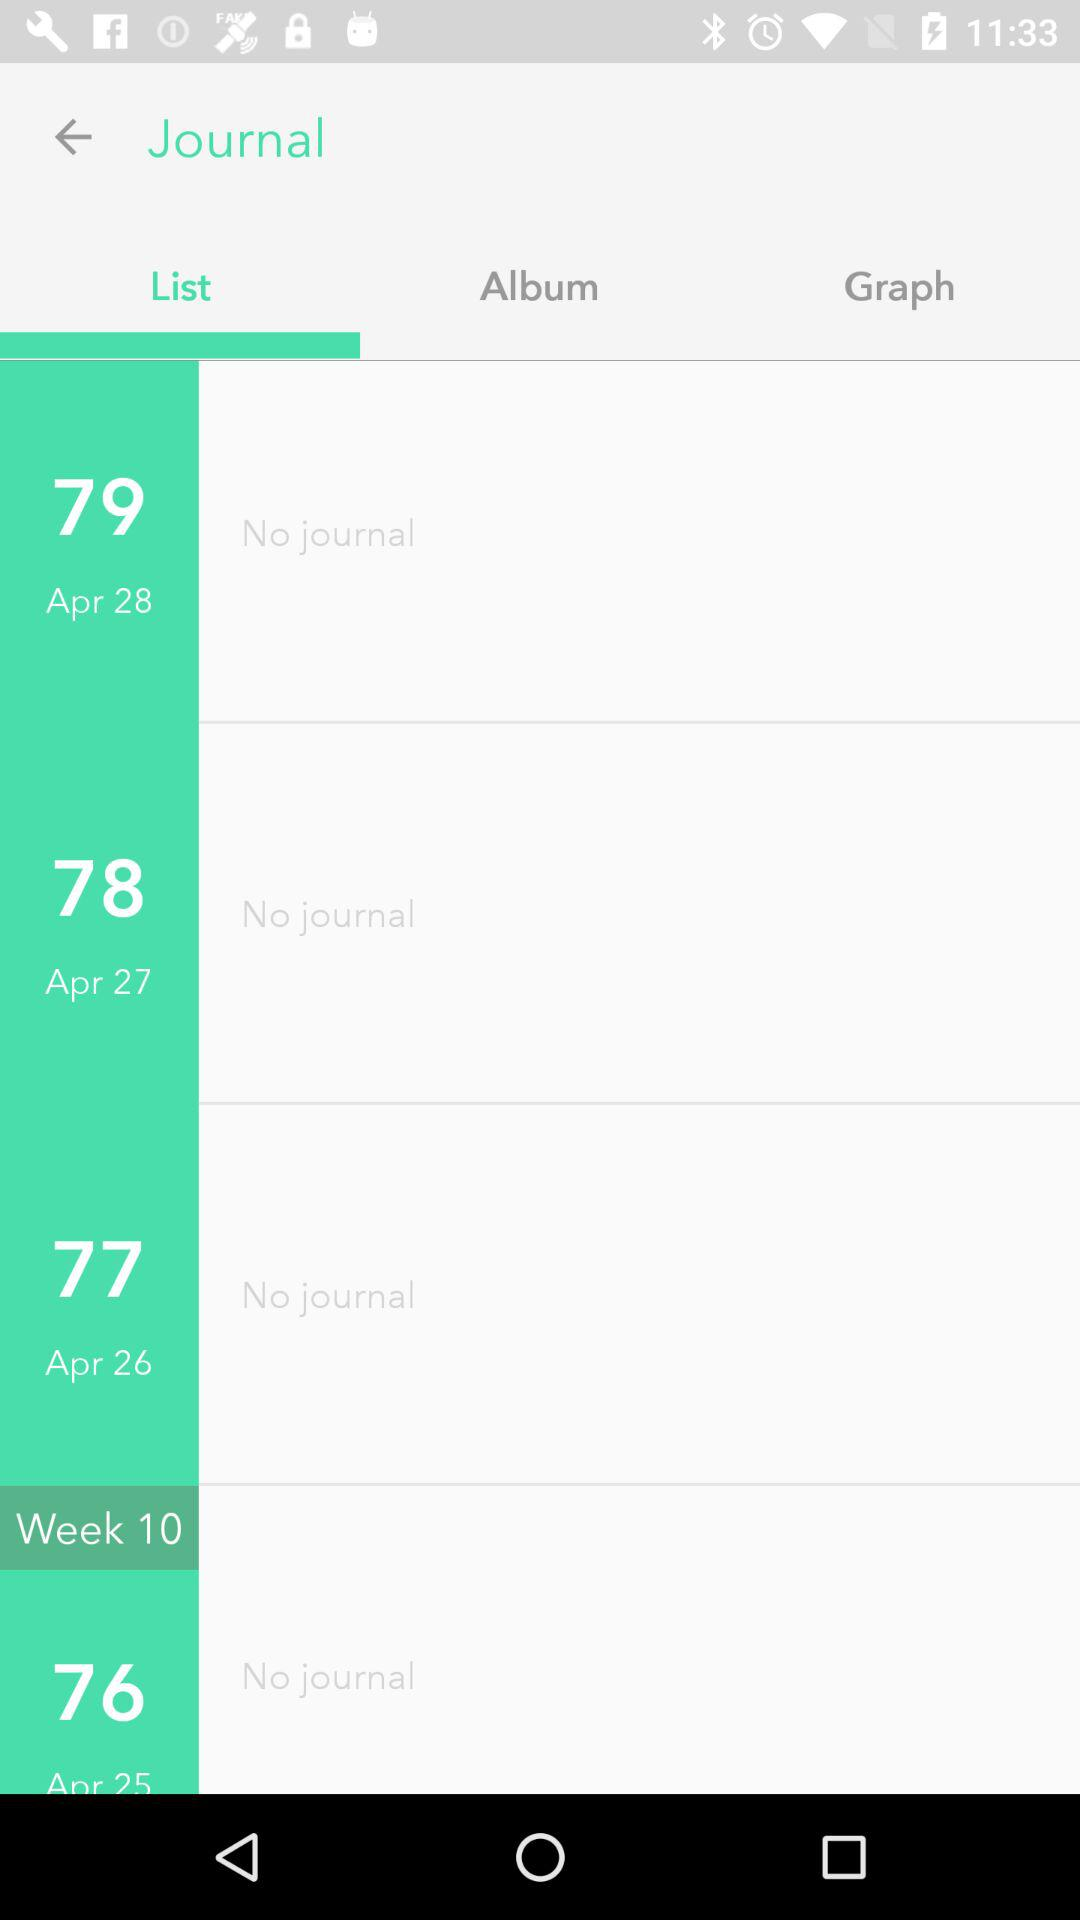How many days do I have no journal entries for?
Answer the question using a single word or phrase. 4 